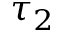<formula> <loc_0><loc_0><loc_500><loc_500>\tau _ { 2 }</formula> 